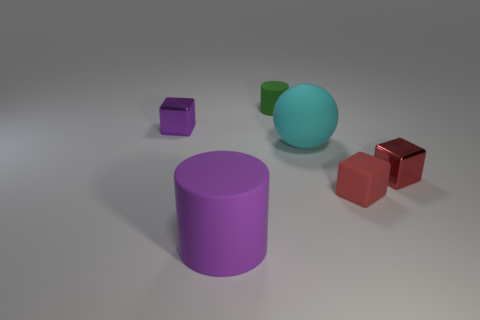Add 3 big cyan balls. How many objects exist? 9 Subtract all red blocks. How many blocks are left? 1 Subtract all purple cylinders. How many cylinders are left? 1 Subtract all spheres. How many objects are left? 5 Subtract 1 cylinders. How many cylinders are left? 1 Subtract all big blue matte balls. Subtract all green rubber objects. How many objects are left? 5 Add 1 tiny cubes. How many tiny cubes are left? 4 Add 4 green objects. How many green objects exist? 5 Subtract 1 cyan spheres. How many objects are left? 5 Subtract all cyan blocks. Subtract all green cylinders. How many blocks are left? 3 